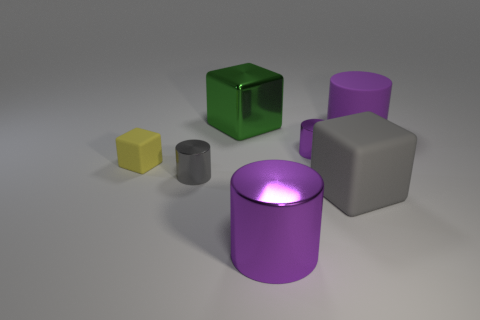Subtract all tiny purple cylinders. How many cylinders are left? 3 Subtract all purple cubes. How many purple cylinders are left? 3 Add 2 yellow rubber objects. How many objects exist? 9 Subtract all blocks. How many objects are left? 4 Subtract 3 cylinders. How many cylinders are left? 1 Subtract all gray cylinders. How many cylinders are left? 3 Subtract all green cylinders. Subtract all red spheres. How many cylinders are left? 4 Subtract all small gray metal objects. Subtract all tiny blue shiny blocks. How many objects are left? 6 Add 1 yellow blocks. How many yellow blocks are left? 2 Add 6 large yellow metal things. How many large yellow metal things exist? 6 